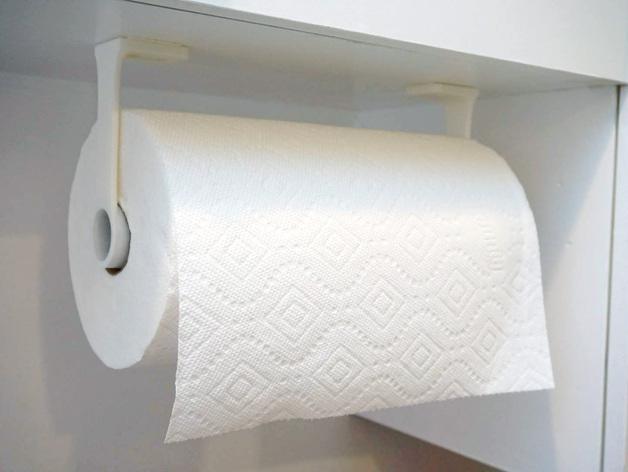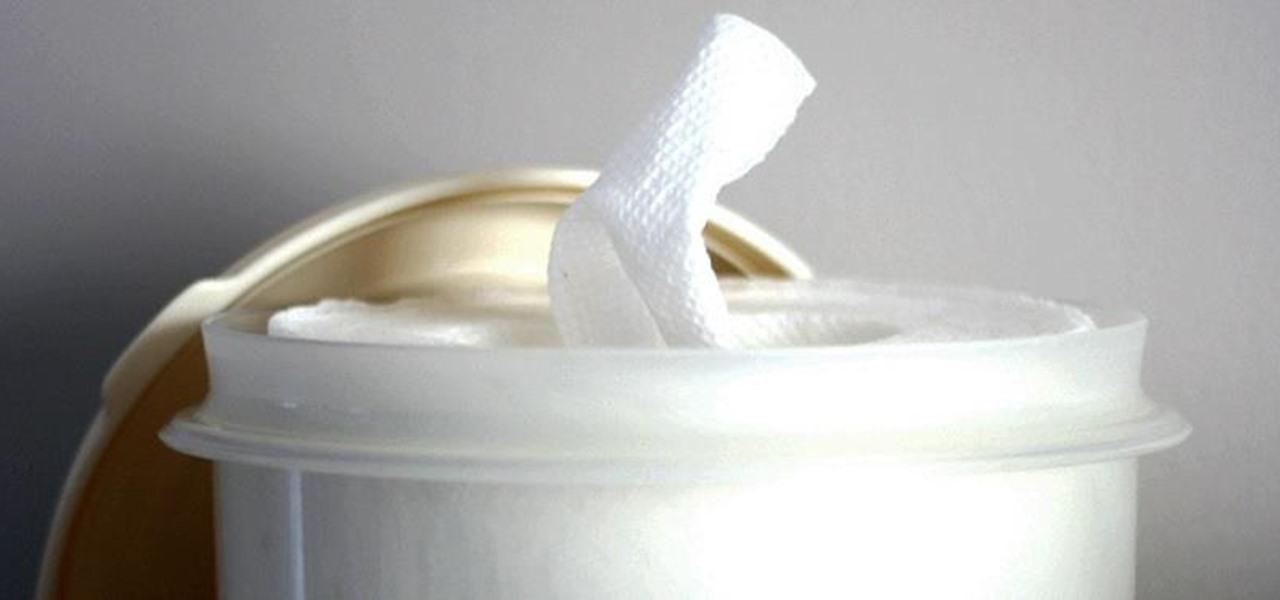The first image is the image on the left, the second image is the image on the right. Given the left and right images, does the statement "The container in the image on the right is round." hold true? Answer yes or no. Yes. 